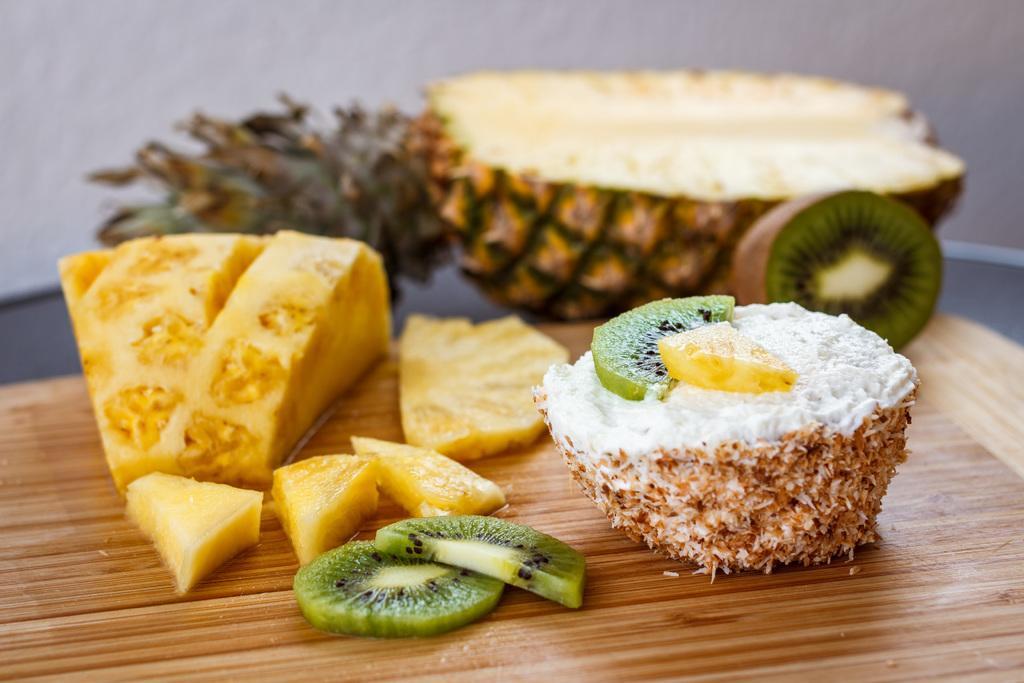Please provide a concise description of this image. In this image we can see some food items on an object. In the background of the image there is a blur background. 